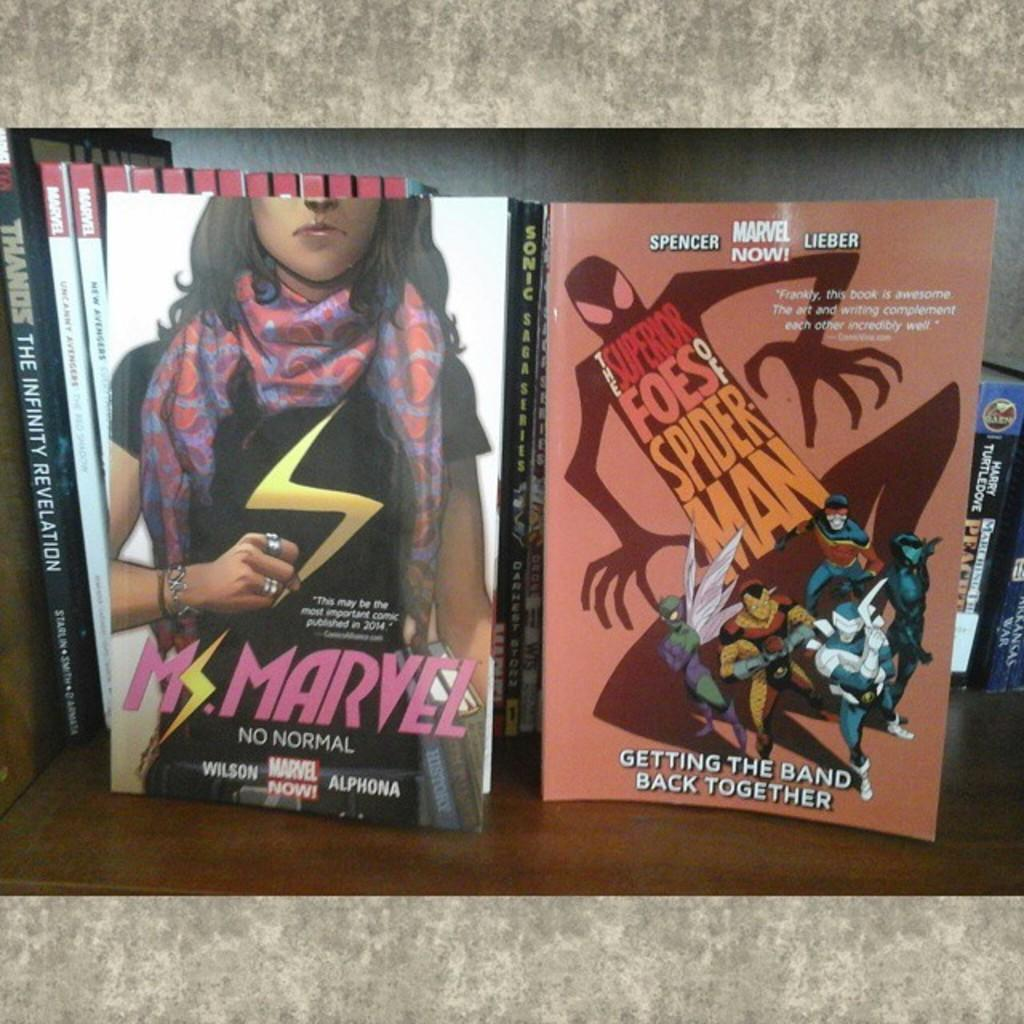<image>
Write a terse but informative summary of the picture. A Book called Ms. Marvel sits on a shelf with its cover facing out. 